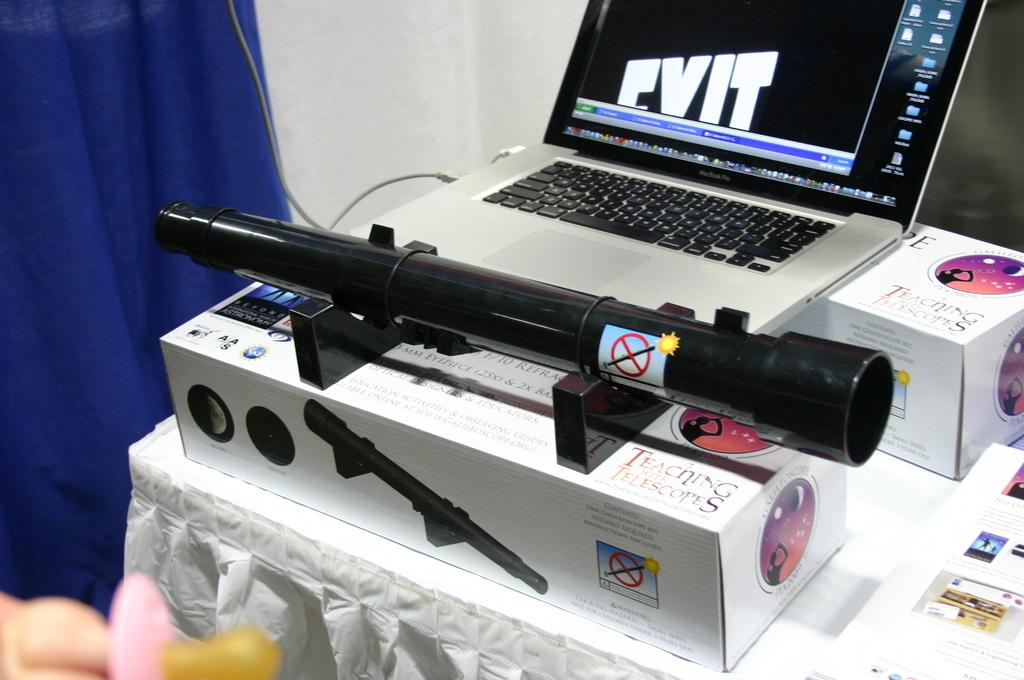<image>
Create a compact narrative representing the image presented. A telescope is atop of the box which reads "teaching with telescopes" 